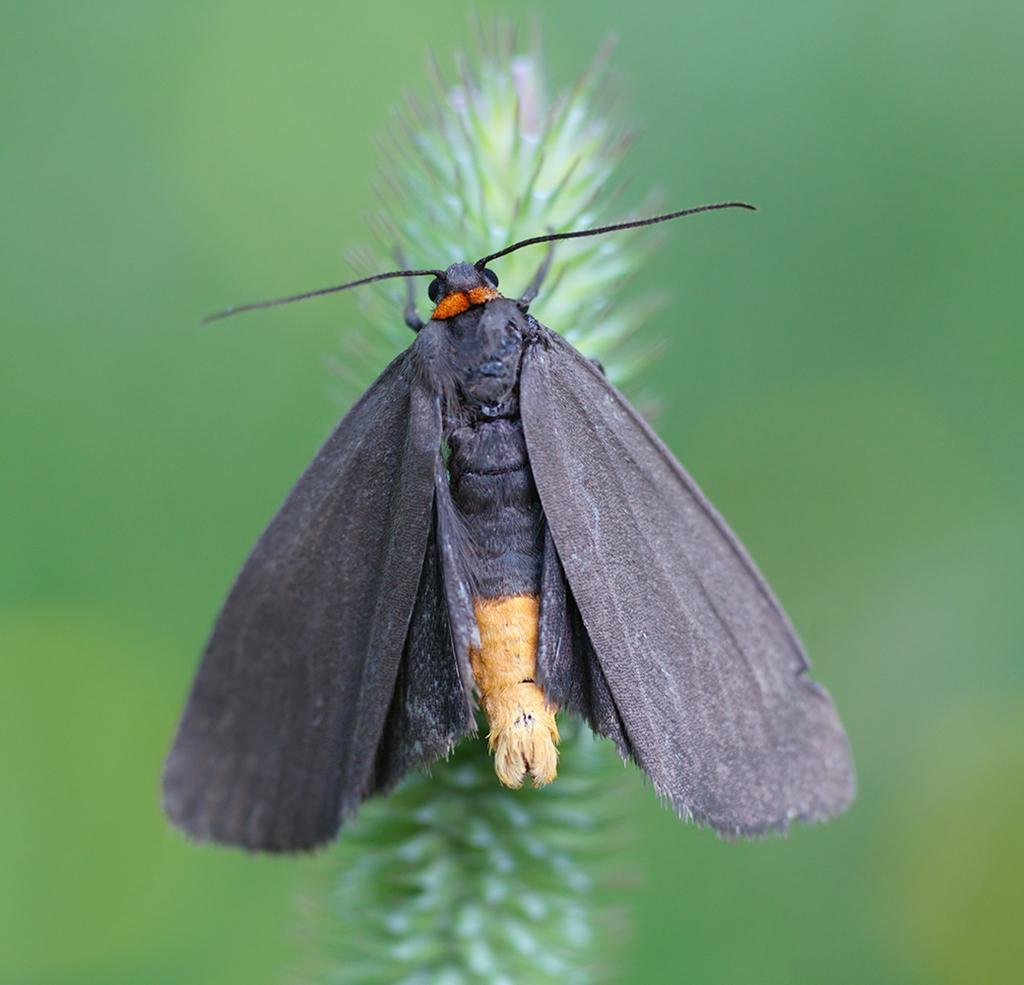Please provide a concise description of this image. There is a butterfly having gray color wings, standing in the flowers of a plant. And the background is blurred. 